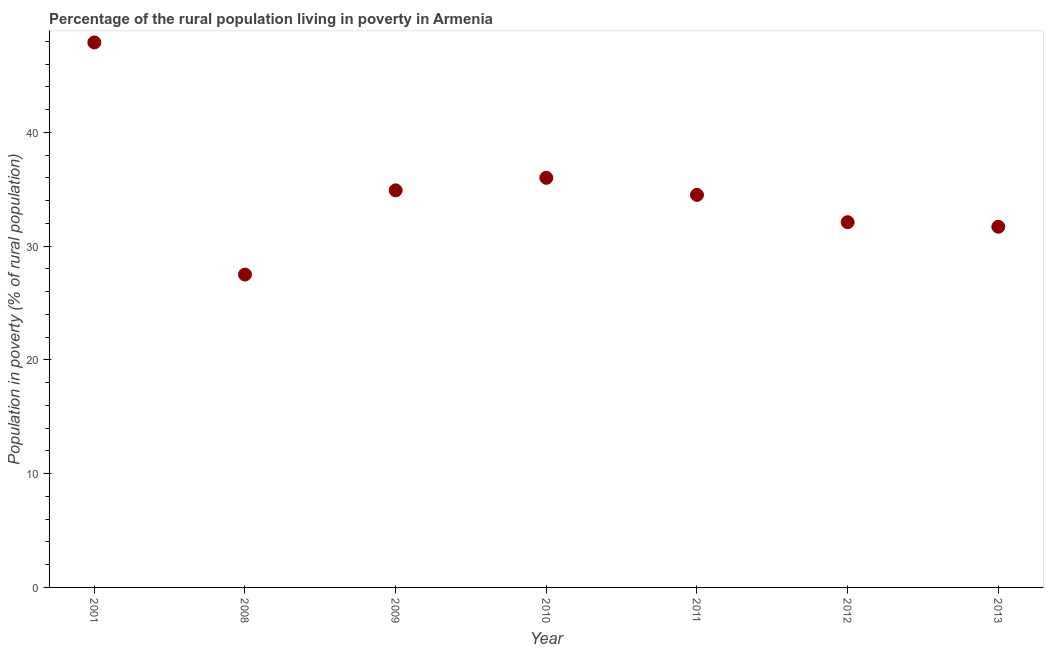What is the percentage of rural population living below poverty line in 2001?
Your answer should be very brief. 47.9. Across all years, what is the maximum percentage of rural population living below poverty line?
Your response must be concise. 47.9. In which year was the percentage of rural population living below poverty line maximum?
Provide a succinct answer. 2001. In which year was the percentage of rural population living below poverty line minimum?
Give a very brief answer. 2008. What is the sum of the percentage of rural population living below poverty line?
Offer a terse response. 244.6. What is the difference between the percentage of rural population living below poverty line in 2001 and 2012?
Make the answer very short. 15.8. What is the average percentage of rural population living below poverty line per year?
Give a very brief answer. 34.94. What is the median percentage of rural population living below poverty line?
Keep it short and to the point. 34.5. Do a majority of the years between 2009 and 2011 (inclusive) have percentage of rural population living below poverty line greater than 20 %?
Give a very brief answer. Yes. What is the ratio of the percentage of rural population living below poverty line in 2009 to that in 2011?
Offer a very short reply. 1.01. Is the percentage of rural population living below poverty line in 2008 less than that in 2013?
Your answer should be very brief. Yes. Is the difference between the percentage of rural population living below poverty line in 2001 and 2008 greater than the difference between any two years?
Keep it short and to the point. Yes. What is the difference between the highest and the second highest percentage of rural population living below poverty line?
Provide a short and direct response. 11.9. Is the sum of the percentage of rural population living below poverty line in 2012 and 2013 greater than the maximum percentage of rural population living below poverty line across all years?
Give a very brief answer. Yes. What is the difference between the highest and the lowest percentage of rural population living below poverty line?
Your answer should be very brief. 20.4. How many dotlines are there?
Provide a succinct answer. 1. How many years are there in the graph?
Your answer should be very brief. 7. Does the graph contain grids?
Your answer should be compact. No. What is the title of the graph?
Your answer should be very brief. Percentage of the rural population living in poverty in Armenia. What is the label or title of the Y-axis?
Your answer should be compact. Population in poverty (% of rural population). What is the Population in poverty (% of rural population) in 2001?
Your response must be concise. 47.9. What is the Population in poverty (% of rural population) in 2008?
Your answer should be very brief. 27.5. What is the Population in poverty (% of rural population) in 2009?
Provide a short and direct response. 34.9. What is the Population in poverty (% of rural population) in 2011?
Give a very brief answer. 34.5. What is the Population in poverty (% of rural population) in 2012?
Your answer should be very brief. 32.1. What is the Population in poverty (% of rural population) in 2013?
Provide a short and direct response. 31.7. What is the difference between the Population in poverty (% of rural population) in 2001 and 2008?
Your answer should be very brief. 20.4. What is the difference between the Population in poverty (% of rural population) in 2001 and 2010?
Provide a succinct answer. 11.9. What is the difference between the Population in poverty (% of rural population) in 2001 and 2011?
Give a very brief answer. 13.4. What is the difference between the Population in poverty (% of rural population) in 2001 and 2012?
Your answer should be compact. 15.8. What is the difference between the Population in poverty (% of rural population) in 2008 and 2010?
Offer a very short reply. -8.5. What is the difference between the Population in poverty (% of rural population) in 2008 and 2011?
Provide a succinct answer. -7. What is the difference between the Population in poverty (% of rural population) in 2009 and 2011?
Make the answer very short. 0.4. What is the difference between the Population in poverty (% of rural population) in 2009 and 2012?
Your answer should be compact. 2.8. What is the difference between the Population in poverty (% of rural population) in 2011 and 2012?
Provide a short and direct response. 2.4. What is the difference between the Population in poverty (% of rural population) in 2011 and 2013?
Make the answer very short. 2.8. What is the ratio of the Population in poverty (% of rural population) in 2001 to that in 2008?
Keep it short and to the point. 1.74. What is the ratio of the Population in poverty (% of rural population) in 2001 to that in 2009?
Provide a succinct answer. 1.37. What is the ratio of the Population in poverty (% of rural population) in 2001 to that in 2010?
Make the answer very short. 1.33. What is the ratio of the Population in poverty (% of rural population) in 2001 to that in 2011?
Provide a succinct answer. 1.39. What is the ratio of the Population in poverty (% of rural population) in 2001 to that in 2012?
Keep it short and to the point. 1.49. What is the ratio of the Population in poverty (% of rural population) in 2001 to that in 2013?
Ensure brevity in your answer.  1.51. What is the ratio of the Population in poverty (% of rural population) in 2008 to that in 2009?
Your response must be concise. 0.79. What is the ratio of the Population in poverty (% of rural population) in 2008 to that in 2010?
Offer a terse response. 0.76. What is the ratio of the Population in poverty (% of rural population) in 2008 to that in 2011?
Provide a short and direct response. 0.8. What is the ratio of the Population in poverty (% of rural population) in 2008 to that in 2012?
Offer a terse response. 0.86. What is the ratio of the Population in poverty (% of rural population) in 2008 to that in 2013?
Give a very brief answer. 0.87. What is the ratio of the Population in poverty (% of rural population) in 2009 to that in 2010?
Your response must be concise. 0.97. What is the ratio of the Population in poverty (% of rural population) in 2009 to that in 2011?
Give a very brief answer. 1.01. What is the ratio of the Population in poverty (% of rural population) in 2009 to that in 2012?
Make the answer very short. 1.09. What is the ratio of the Population in poverty (% of rural population) in 2009 to that in 2013?
Keep it short and to the point. 1.1. What is the ratio of the Population in poverty (% of rural population) in 2010 to that in 2011?
Offer a terse response. 1.04. What is the ratio of the Population in poverty (% of rural population) in 2010 to that in 2012?
Give a very brief answer. 1.12. What is the ratio of the Population in poverty (% of rural population) in 2010 to that in 2013?
Your answer should be very brief. 1.14. What is the ratio of the Population in poverty (% of rural population) in 2011 to that in 2012?
Your answer should be very brief. 1.07. What is the ratio of the Population in poverty (% of rural population) in 2011 to that in 2013?
Keep it short and to the point. 1.09. What is the ratio of the Population in poverty (% of rural population) in 2012 to that in 2013?
Provide a short and direct response. 1.01. 